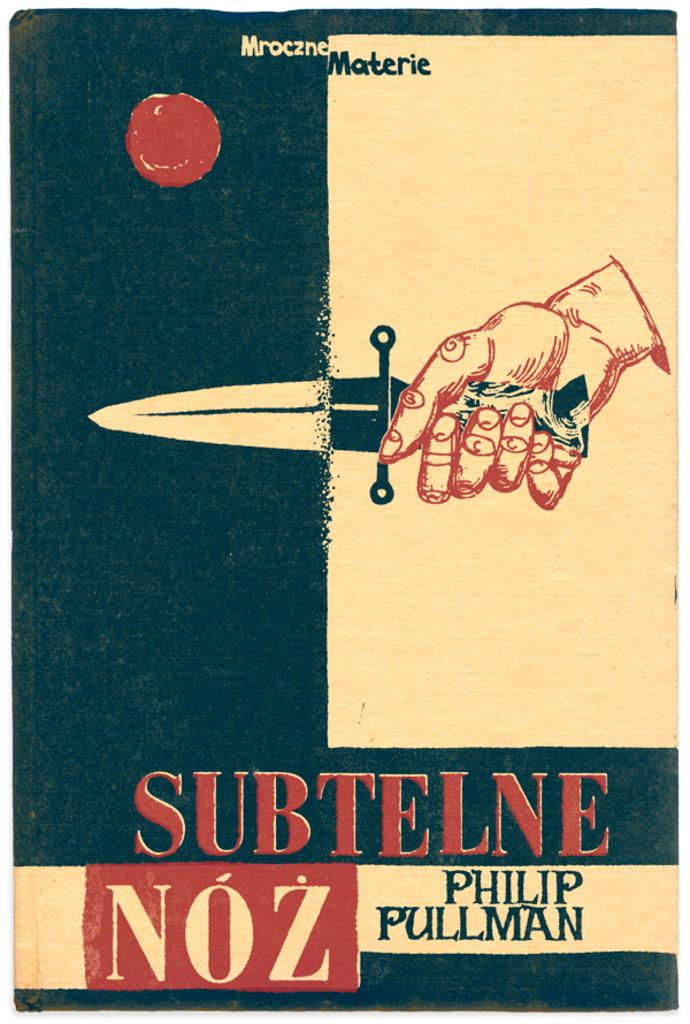<image>
Give a short and clear explanation of the subsequent image. A book cover is shown with an author of Philip Pullman. 